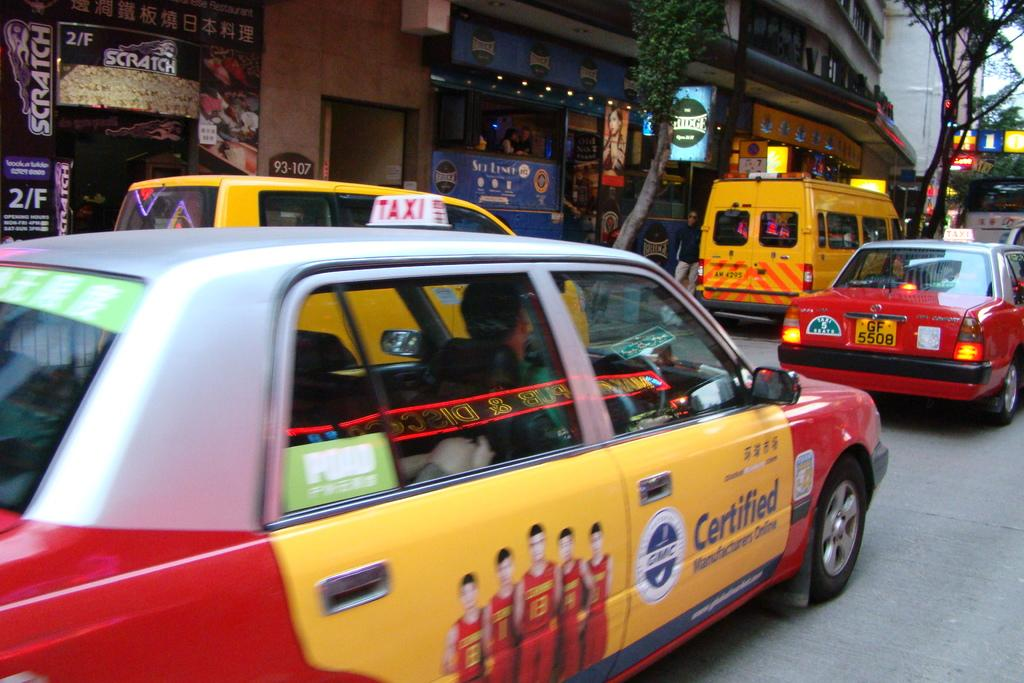What can be seen in the image? There are vehicles in the image. What is visible in the background of the image? There are stalls, posters, and trees in the background of the image. How many pockets are visible on the vehicles in the image? There are no pockets visible on the vehicles in the image, as vehicles do not have pockets. 